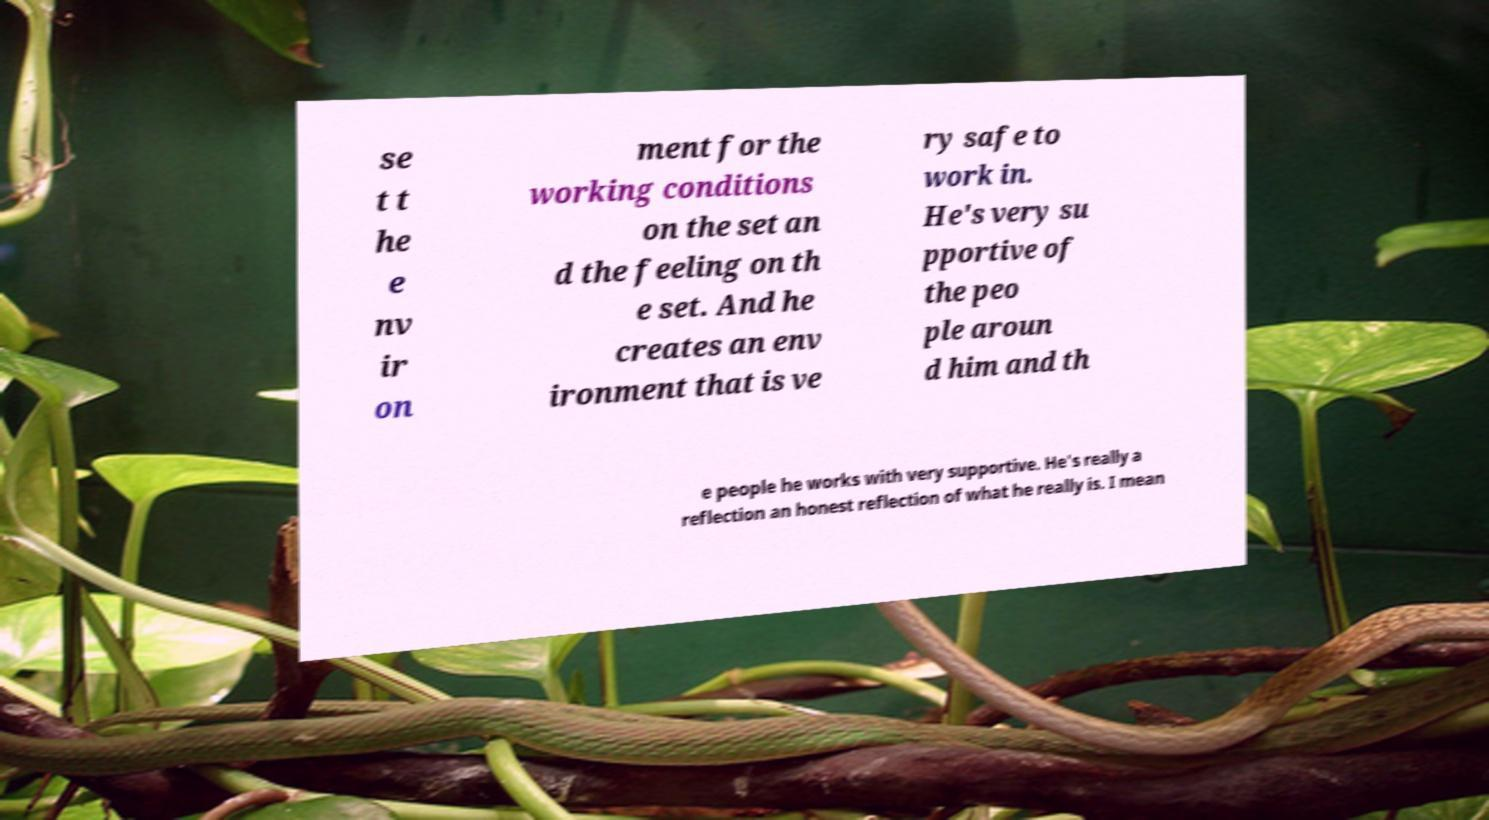Please read and relay the text visible in this image. What does it say? se t t he e nv ir on ment for the working conditions on the set an d the feeling on th e set. And he creates an env ironment that is ve ry safe to work in. He's very su pportive of the peo ple aroun d him and th e people he works with very supportive. He's really a reflection an honest reflection of what he really is. I mean 